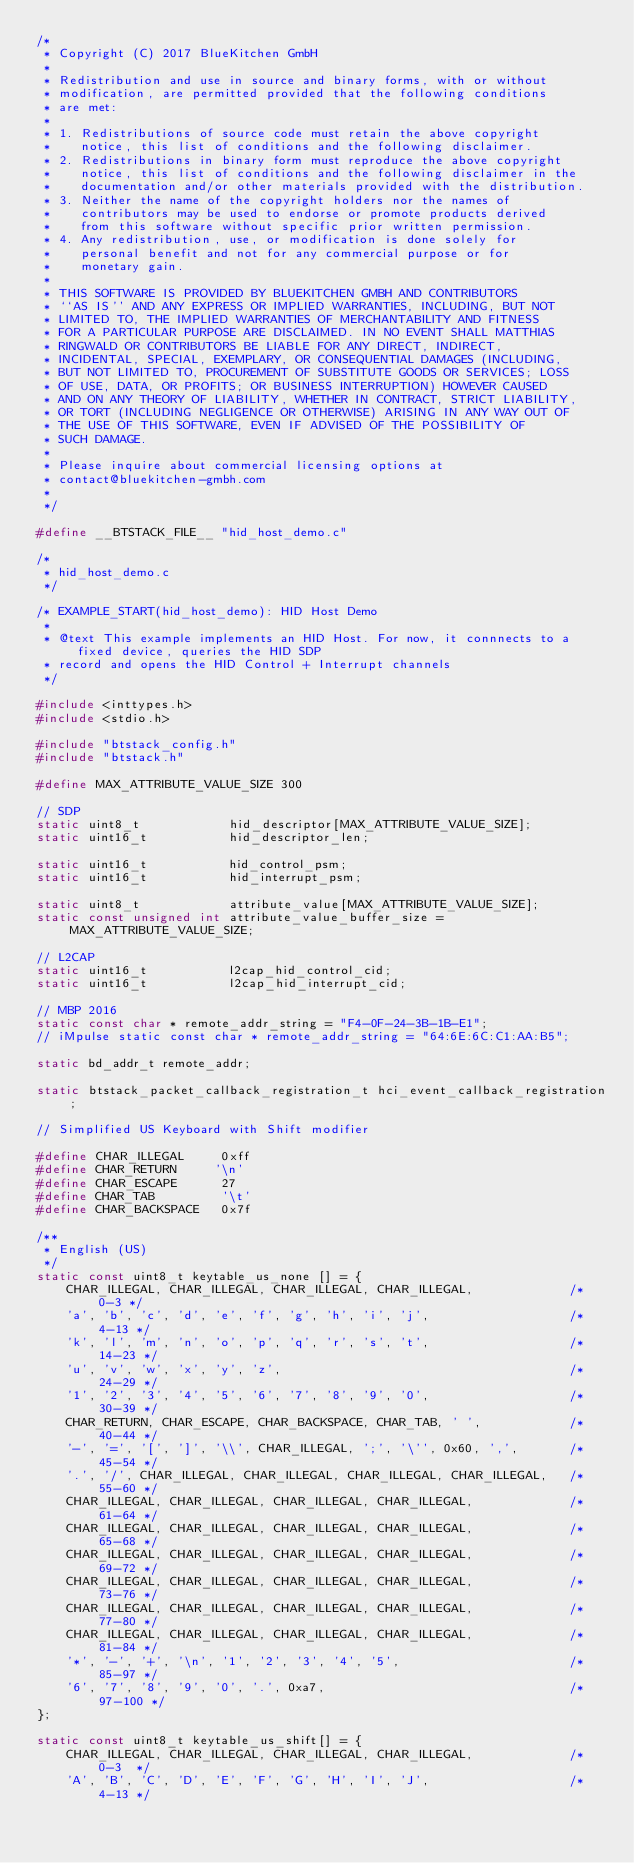Convert code to text. <code><loc_0><loc_0><loc_500><loc_500><_C_>/*
 * Copyright (C) 2017 BlueKitchen GmbH
 *
 * Redistribution and use in source and binary forms, with or without
 * modification, are permitted provided that the following conditions
 * are met:
 *
 * 1. Redistributions of source code must retain the above copyright
 *    notice, this list of conditions and the following disclaimer.
 * 2. Redistributions in binary form must reproduce the above copyright
 *    notice, this list of conditions and the following disclaimer in the
 *    documentation and/or other materials provided with the distribution.
 * 3. Neither the name of the copyright holders nor the names of
 *    contributors may be used to endorse or promote products derived
 *    from this software without specific prior written permission.
 * 4. Any redistribution, use, or modification is done solely for
 *    personal benefit and not for any commercial purpose or for
 *    monetary gain.
 *
 * THIS SOFTWARE IS PROVIDED BY BLUEKITCHEN GMBH AND CONTRIBUTORS
 * ``AS IS'' AND ANY EXPRESS OR IMPLIED WARRANTIES, INCLUDING, BUT NOT
 * LIMITED TO, THE IMPLIED WARRANTIES OF MERCHANTABILITY AND FITNESS
 * FOR A PARTICULAR PURPOSE ARE DISCLAIMED. IN NO EVENT SHALL MATTHIAS
 * RINGWALD OR CONTRIBUTORS BE LIABLE FOR ANY DIRECT, INDIRECT,
 * INCIDENTAL, SPECIAL, EXEMPLARY, OR CONSEQUENTIAL DAMAGES (INCLUDING,
 * BUT NOT LIMITED TO, PROCUREMENT OF SUBSTITUTE GOODS OR SERVICES; LOSS
 * OF USE, DATA, OR PROFITS; OR BUSINESS INTERRUPTION) HOWEVER CAUSED
 * AND ON ANY THEORY OF LIABILITY, WHETHER IN CONTRACT, STRICT LIABILITY,
 * OR TORT (INCLUDING NEGLIGENCE OR OTHERWISE) ARISING IN ANY WAY OUT OF
 * THE USE OF THIS SOFTWARE, EVEN IF ADVISED OF THE POSSIBILITY OF
 * SUCH DAMAGE.
 *
 * Please inquire about commercial licensing options at 
 * contact@bluekitchen-gmbh.com
 *
 */

#define __BTSTACK_FILE__ "hid_host_demo.c"

/*
 * hid_host_demo.c
 */

/* EXAMPLE_START(hid_host_demo): HID Host Demo
 *
 * @text This example implements an HID Host. For now, it connnects to a fixed device, queries the HID SDP
 * record and opens the HID Control + Interrupt channels
 */

#include <inttypes.h>
#include <stdio.h>

#include "btstack_config.h"
#include "btstack.h"

#define MAX_ATTRIBUTE_VALUE_SIZE 300

// SDP
static uint8_t            hid_descriptor[MAX_ATTRIBUTE_VALUE_SIZE];
static uint16_t           hid_descriptor_len;

static uint16_t           hid_control_psm;
static uint16_t           hid_interrupt_psm;

static uint8_t            attribute_value[MAX_ATTRIBUTE_VALUE_SIZE];
static const unsigned int attribute_value_buffer_size = MAX_ATTRIBUTE_VALUE_SIZE;

// L2CAP
static uint16_t           l2cap_hid_control_cid;
static uint16_t           l2cap_hid_interrupt_cid;

// MBP 2016
static const char * remote_addr_string = "F4-0F-24-3B-1B-E1";
// iMpulse static const char * remote_addr_string = "64:6E:6C:C1:AA:B5";

static bd_addr_t remote_addr;

static btstack_packet_callback_registration_t hci_event_callback_registration;

// Simplified US Keyboard with Shift modifier

#define CHAR_ILLEGAL     0xff
#define CHAR_RETURN     '\n'
#define CHAR_ESCAPE      27
#define CHAR_TAB         '\t'
#define CHAR_BACKSPACE   0x7f

/**
 * English (US)
 */
static const uint8_t keytable_us_none [] = {
    CHAR_ILLEGAL, CHAR_ILLEGAL, CHAR_ILLEGAL, CHAR_ILLEGAL,             /*   0-3 */
    'a', 'b', 'c', 'd', 'e', 'f', 'g', 'h', 'i', 'j',                   /*  4-13 */
    'k', 'l', 'm', 'n', 'o', 'p', 'q', 'r', 's', 't',                   /* 14-23 */
    'u', 'v', 'w', 'x', 'y', 'z',                                       /* 24-29 */
    '1', '2', '3', '4', '5', '6', '7', '8', '9', '0',                   /* 30-39 */
    CHAR_RETURN, CHAR_ESCAPE, CHAR_BACKSPACE, CHAR_TAB, ' ',            /* 40-44 */
    '-', '=', '[', ']', '\\', CHAR_ILLEGAL, ';', '\'', 0x60, ',',       /* 45-54 */
    '.', '/', CHAR_ILLEGAL, CHAR_ILLEGAL, CHAR_ILLEGAL, CHAR_ILLEGAL,   /* 55-60 */
    CHAR_ILLEGAL, CHAR_ILLEGAL, CHAR_ILLEGAL, CHAR_ILLEGAL,             /* 61-64 */
    CHAR_ILLEGAL, CHAR_ILLEGAL, CHAR_ILLEGAL, CHAR_ILLEGAL,             /* 65-68 */
    CHAR_ILLEGAL, CHAR_ILLEGAL, CHAR_ILLEGAL, CHAR_ILLEGAL,             /* 69-72 */
    CHAR_ILLEGAL, CHAR_ILLEGAL, CHAR_ILLEGAL, CHAR_ILLEGAL,             /* 73-76 */
    CHAR_ILLEGAL, CHAR_ILLEGAL, CHAR_ILLEGAL, CHAR_ILLEGAL,             /* 77-80 */
    CHAR_ILLEGAL, CHAR_ILLEGAL, CHAR_ILLEGAL, CHAR_ILLEGAL,             /* 81-84 */
    '*', '-', '+', '\n', '1', '2', '3', '4', '5',                       /* 85-97 */
    '6', '7', '8', '9', '0', '.', 0xa7,                                 /* 97-100 */
}; 

static const uint8_t keytable_us_shift[] = {
    CHAR_ILLEGAL, CHAR_ILLEGAL, CHAR_ILLEGAL, CHAR_ILLEGAL,             /*  0-3  */
    'A', 'B', 'C', 'D', 'E', 'F', 'G', 'H', 'I', 'J',                   /*  4-13 */</code> 